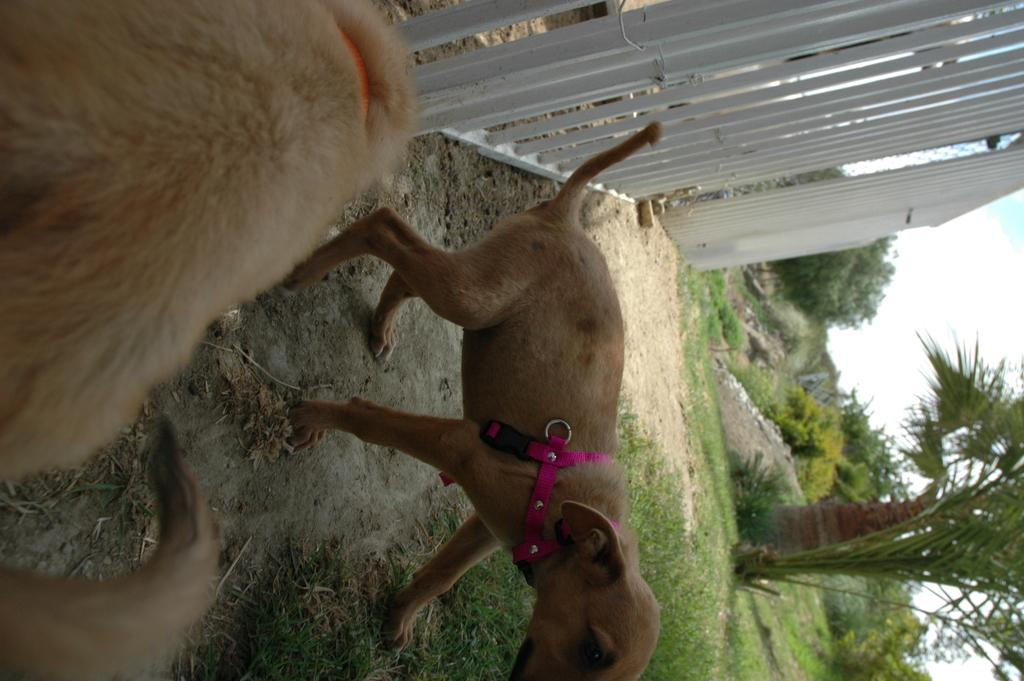What type of animals are wearing belts in the image? There are dogs with belts in the image. What can be seen in the background of the image? There is a fence, trees, plants, and grass in the image. What is visible in the sky in the image? The sky is visible in the image, and there are clouds in the sky. What type of birthday celebration is taking place in the image? There is no indication of a birthday celebration in the image. Can you tell me where the basin is located in the image? There is no basin present in the image. 